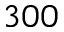Convert formula to latex. <formula><loc_0><loc_0><loc_500><loc_500>3 0 0</formula> 